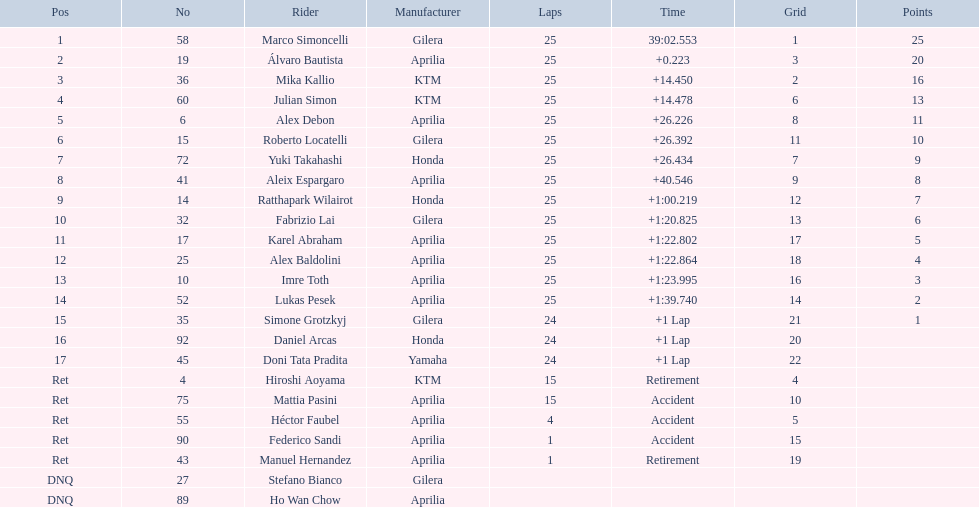What was the speediest combined time? 39:02.553. To whom does this time belong? Marco Simoncelli. 